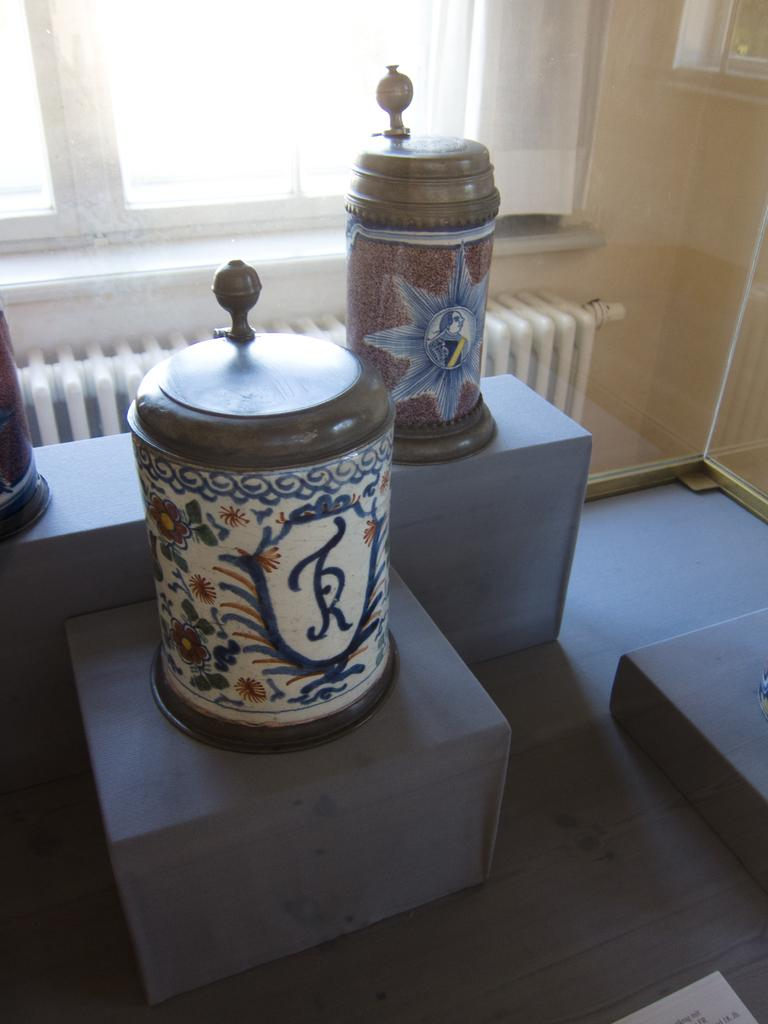What type of containers are visible in the image? There are jars and boxes in the image. What type of barrier is present in the image? There is a glass wall in the image. What type of opening is present in the image? There is a window in the image. What type of covering is present in the image? There is a curtain in the image. Can you describe any other objects in the image? There are unspecified objects in the image. What type of language is spoken by the potatoes in the image? There are no potatoes present in the image, so it is not possible to determine what language they might speak. 